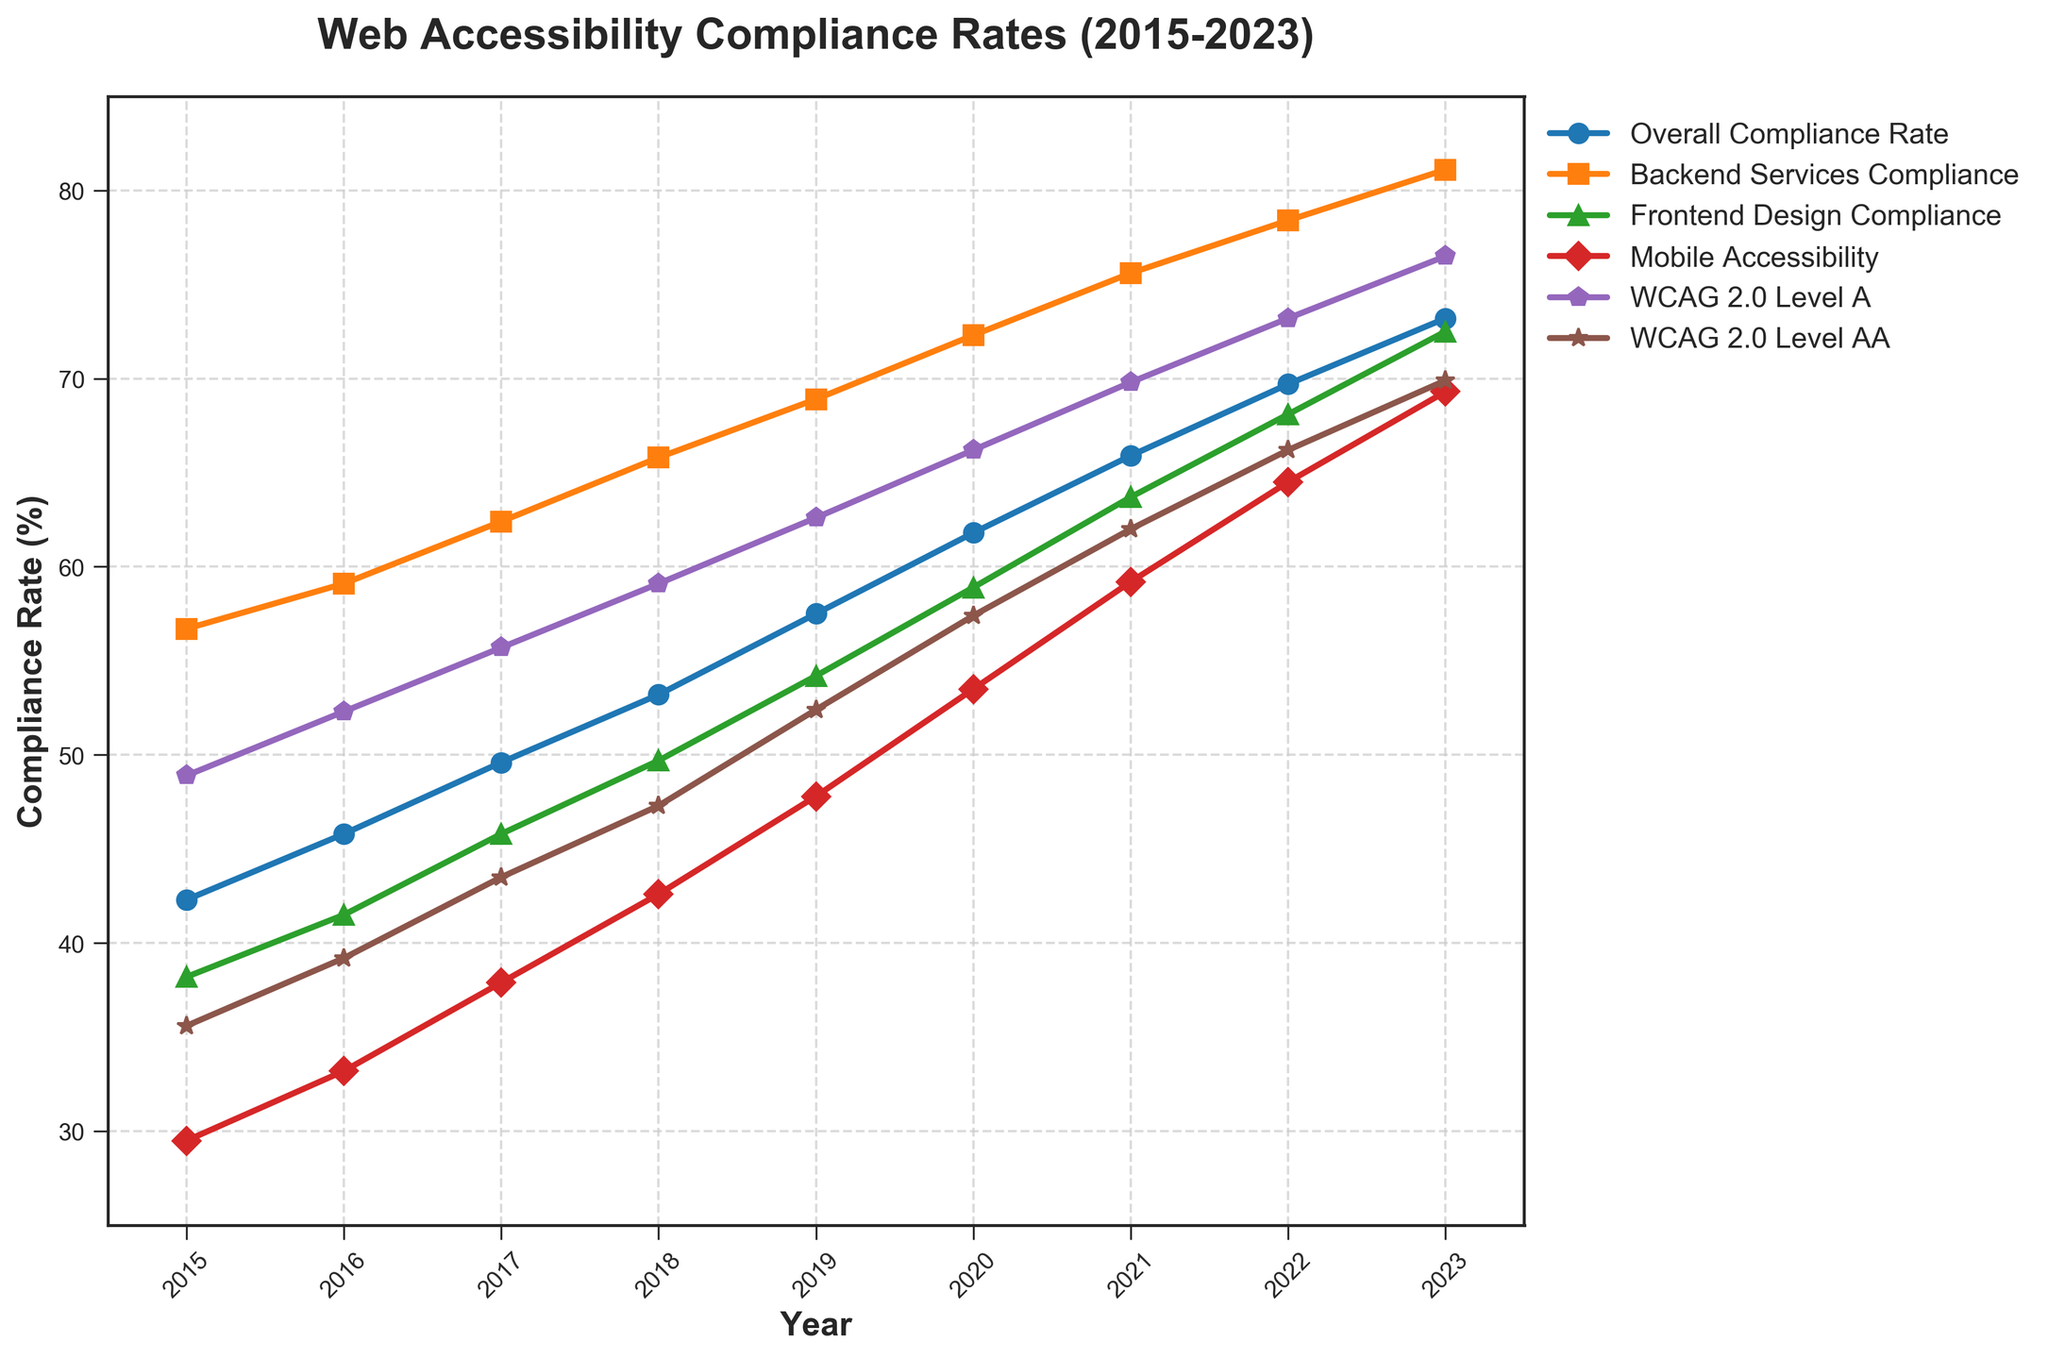What trend do you observe in the Overall Compliance Rate from 2015 to 2023? Look at the line representing the Overall Compliance Rate from 2015 to 2023. It shows a consistent upward trend, starting from 42.3% in 2015 and reaching 73.2% in 2023.
Answer: Upward trend Which year saw the highest compliance rate for Mobile Accessibility? Identify the peak value on the line representing Mobile Accessibility. The highest compliance rate occurred in 2023 with a value of 69.3%.
Answer: 2023 By how much did the Backend Services Compliance rate increase from 2015 to 2023? Subtract the Backend Services Compliance rate in 2015 from the rate in 2023: 81.1% - 56.7% = 24.4%.
Answer: 24.4% Which compliance category had the smallest improvement from 2015 to 2023? Calculate the difference for each category between 2015 and 2023. Mobile Accessibility increased from 29.5% to 69.3%, an increase of 39.8%. WCAG 2.0 Level AA increased from 35.6% to 69.9%, an increase of 34.3%. WCAG 2.0 Level A increased from 48.9% to 76.5%, an increase of 27.6%. Frontend Design Compliance increased from 38.2% to 72.5%, an increase of 34.3%. Backend Services Compliance increased from 56.7% to 81.1%, an increase of 24.4%. Overall Compliance Rate increased from 42.3% to 73.2%, an increase of 30.9%. So, Backend Services Compliance had the smallest improvement.
Answer: Backend Services Compliance Compare the compliance rates of Frontend Design Compliance in 2017 and Mobile Accessibility in 2019. Which was higher? Find the Frontend Design Compliance rate in 2017 (45.8%) and compare it to the Mobile Accessibility rate in 2019 (47.8%). Mobile Accessibility in 2019 is higher.
Answer: Mobile Accessibility in 2019 Which compliance category had the highest rate in 2018? Compare all categories' rates in 2018. Backend Services Compliance had the highest rate at 65.8%.
Answer: Backend Services Compliance Did the Overall Compliance Rate ever decrease from one year to the next? Examine the Overall Compliance Rate line for any declines. The line consistently rises from 2015 to 2023, indicating no decrease.
Answer: No What was the average improvement rate per year for WCAG 2.0 Level AA from 2015 to 2023? Calculate the total improvement from 2015 (35.6%) to 2023 (69.9%), which is 69.9% - 35.6% = 34.3%. Divide this by the number of years (2023 - 2015 = 8 years), so the average improvement rate per year is 34.3% / 8 ≈ 4.29%.
Answer: 4.29% How does the compliance rate of Frontend Design Compliance in 2022 compare to Backend Services Compliance in the same year? Locate the rates for both categories in 2022: Frontend Design Compliance is 68.1%, and Backend Services Compliance is 78.4%. Backend Services Compliance is higher.
Answer: Backend Services Compliance is higher Which compliance category showed a larger percentage increase from 2015 to 2020, WCAG 2.0 Level A or WCAG 2.0 Level AA? Calculate the percentage increase for both categories:
- WCAG 2.0 Level A: (66.2% - 48.9%) / 48.9% * 100 ≈ 35.36%
- WCAG 2.0 Level AA: (57.4% - 35.6%) / 35.6% * 100 ≈ 61.24%
WCAG 2.0 Level AA showed a larger percentage increase.
Answer: WCAG 2.0 Level AA 